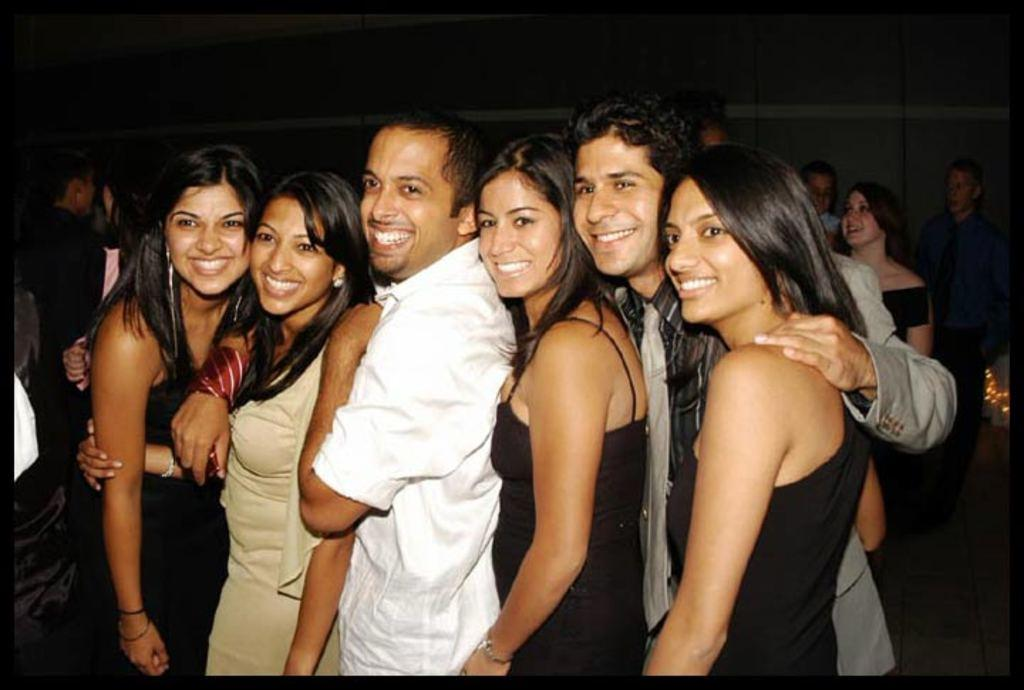What is the main subject of the image? The main subject of the image is people standing in a row. Can you describe the positioning of the people in the image? The people are standing in a row. What can be seen in the background of the image? In the background of the image, there are other persons standing on the floor. What type of sticks are the dad using to play the current in the image? There is no dad, sticks, or current present in the image. 